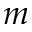Convert formula to latex. <formula><loc_0><loc_0><loc_500><loc_500>m</formula> 